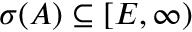<formula> <loc_0><loc_0><loc_500><loc_500>\sigma ( A ) \subseteq [ E , \infty )</formula> 